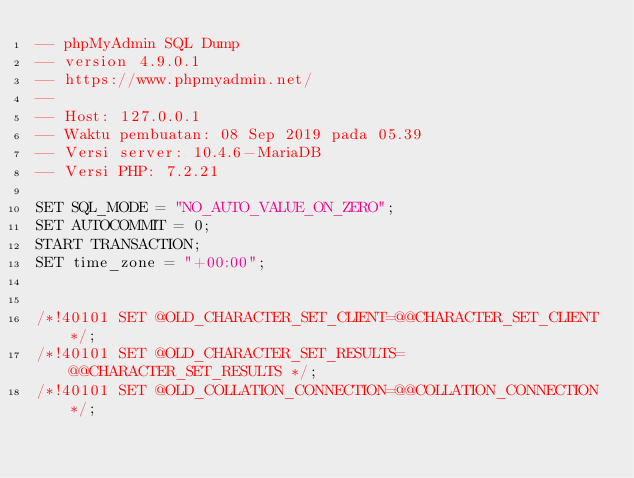<code> <loc_0><loc_0><loc_500><loc_500><_SQL_>-- phpMyAdmin SQL Dump
-- version 4.9.0.1
-- https://www.phpmyadmin.net/
--
-- Host: 127.0.0.1
-- Waktu pembuatan: 08 Sep 2019 pada 05.39
-- Versi server: 10.4.6-MariaDB
-- Versi PHP: 7.2.21

SET SQL_MODE = "NO_AUTO_VALUE_ON_ZERO";
SET AUTOCOMMIT = 0;
START TRANSACTION;
SET time_zone = "+00:00";


/*!40101 SET @OLD_CHARACTER_SET_CLIENT=@@CHARACTER_SET_CLIENT */;
/*!40101 SET @OLD_CHARACTER_SET_RESULTS=@@CHARACTER_SET_RESULTS */;
/*!40101 SET @OLD_COLLATION_CONNECTION=@@COLLATION_CONNECTION */;</code> 